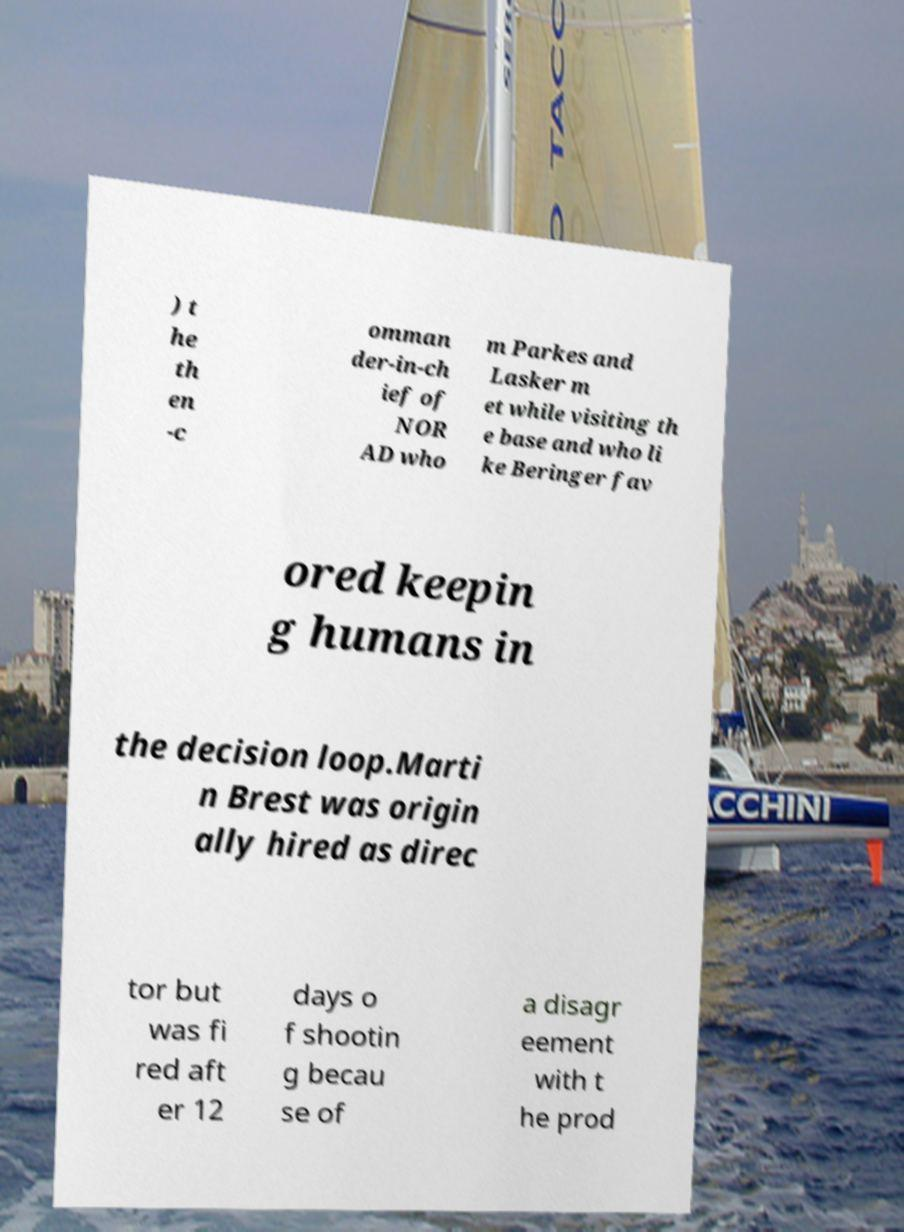Could you assist in decoding the text presented in this image and type it out clearly? ) t he th en -c omman der-in-ch ief of NOR AD who m Parkes and Lasker m et while visiting th e base and who li ke Beringer fav ored keepin g humans in the decision loop.Marti n Brest was origin ally hired as direc tor but was fi red aft er 12 days o f shootin g becau se of a disagr eement with t he prod 